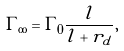Convert formula to latex. <formula><loc_0><loc_0><loc_500><loc_500>\Gamma _ { \infty } = \Gamma _ { 0 } \frac { l } { l + r _ { d } } ,</formula> 